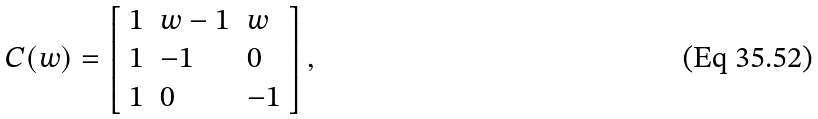<formula> <loc_0><loc_0><loc_500><loc_500>C ( w ) = \left [ \begin{array} { l l l } { 1 } & { w - 1 } & { w } \\ { 1 } & { - 1 } & { 0 } \\ { 1 } & { 0 } & { - 1 } \end{array} \right ] ,</formula> 